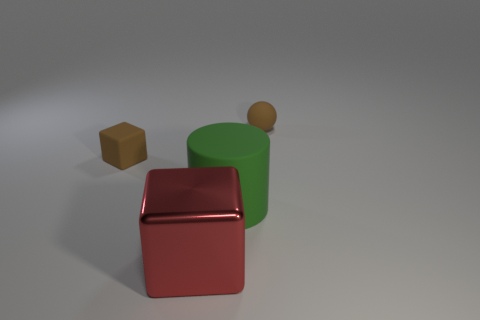Can you describe the lighting in this scene? The image features soft, diffuse lighting with subtle shadows cast by the objects, suggesting an overhead light source with a possible slight angle, as evidenced by the gentle gradients on the surface and sides of the objects. 